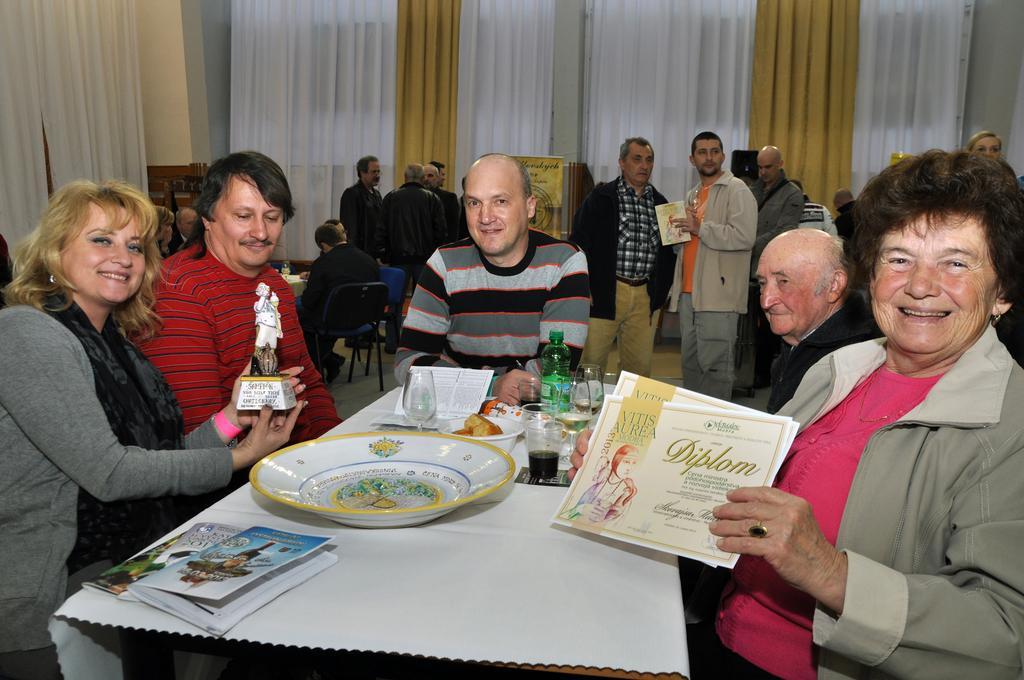Describe this image in one or two sentences. This picture is clicked inside a restaurant. There are people sitting on chairs at the table. There is a cloth spread on the table. On the table there is a plate, books, bowls, food, bottles and glasses. The woman at the left corner is holding a memento. The woman to the right corner is smiling and holding the certificate. In the background there are people standing. There are also curtains and wall in the background.  